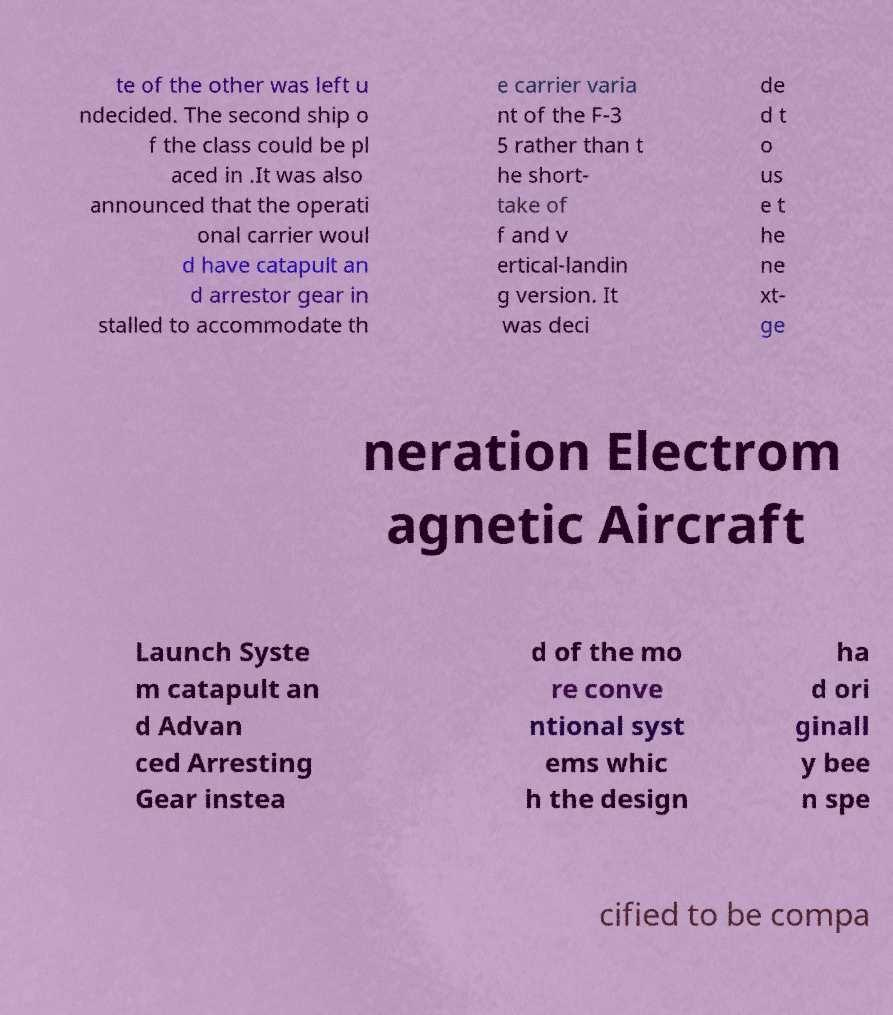Please read and relay the text visible in this image. What does it say? te of the other was left u ndecided. The second ship o f the class could be pl aced in .It was also announced that the operati onal carrier woul d have catapult an d arrestor gear in stalled to accommodate th e carrier varia nt of the F-3 5 rather than t he short- take of f and v ertical-landin g version. It was deci de d t o us e t he ne xt- ge neration Electrom agnetic Aircraft Launch Syste m catapult an d Advan ced Arresting Gear instea d of the mo re conve ntional syst ems whic h the design ha d ori ginall y bee n spe cified to be compa 